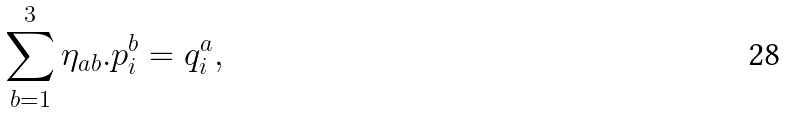<formula> <loc_0><loc_0><loc_500><loc_500>\sum _ { b = 1 } ^ { 3 } \eta _ { a b } . p ^ { b } _ { i } = q ^ { a } _ { i } ,</formula> 